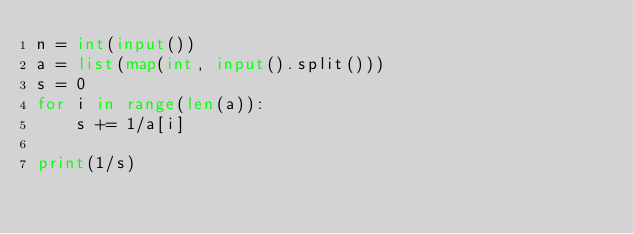Convert code to text. <code><loc_0><loc_0><loc_500><loc_500><_Python_>n = int(input())
a = list(map(int, input().split()))
s = 0
for i in range(len(a)):
	s += 1/a[i]

print(1/s)</code> 